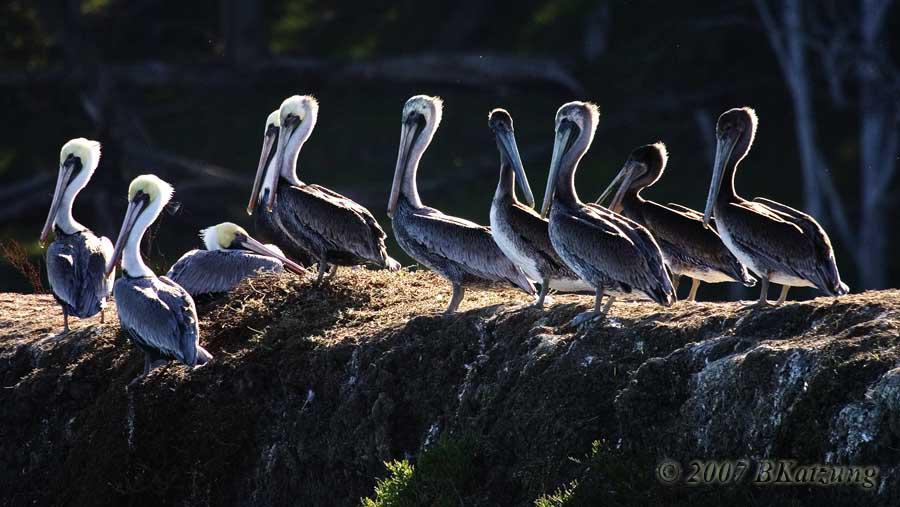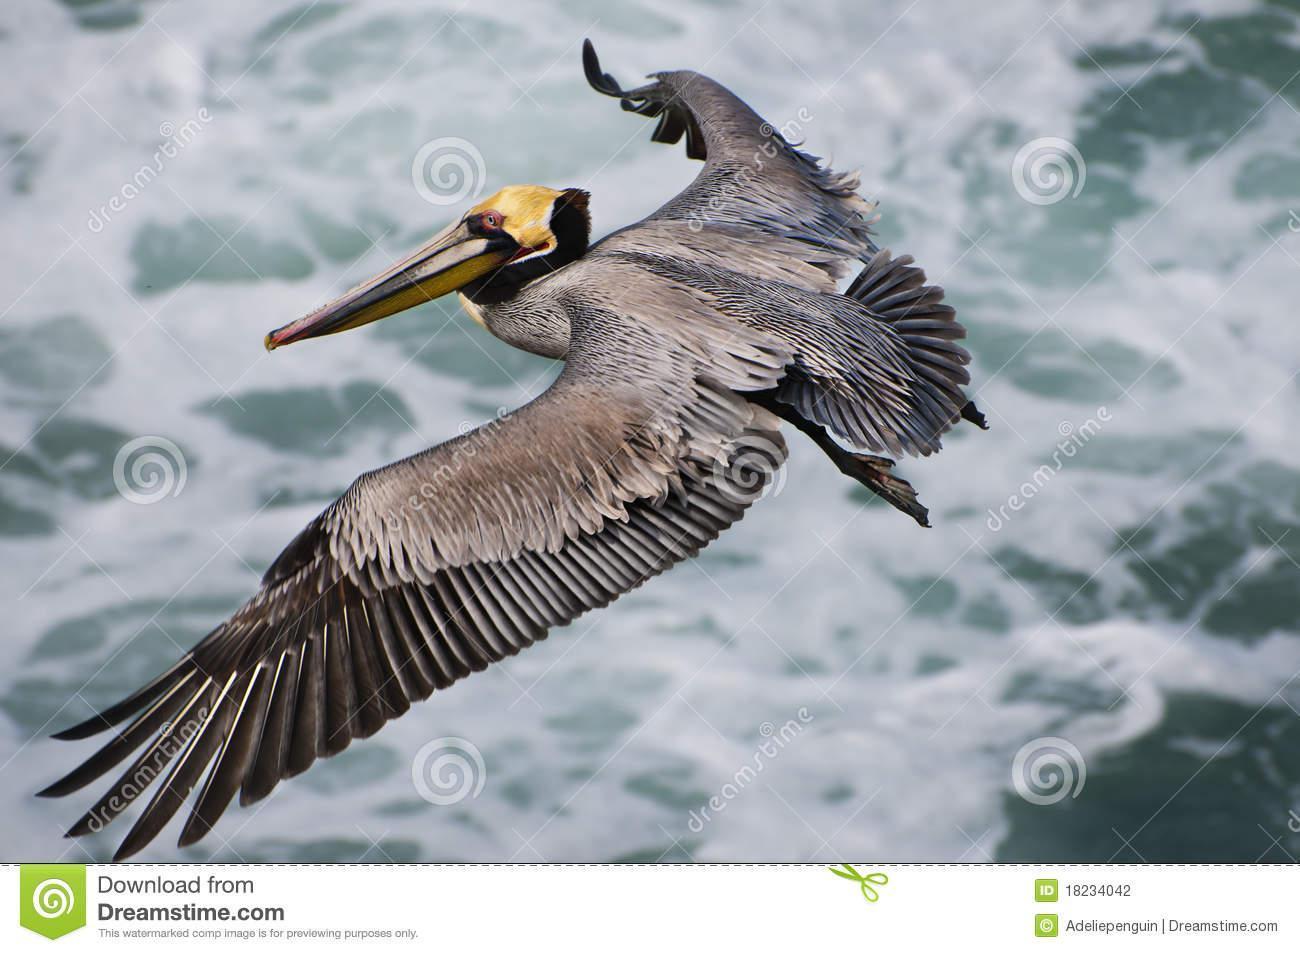The first image is the image on the left, the second image is the image on the right. Assess this claim about the two images: "there is a flying bird in the image on the right". Correct or not? Answer yes or no. Yes. The first image is the image on the left, the second image is the image on the right. Examine the images to the left and right. Is the description "At least one bird is flying." accurate? Answer yes or no. Yes. 